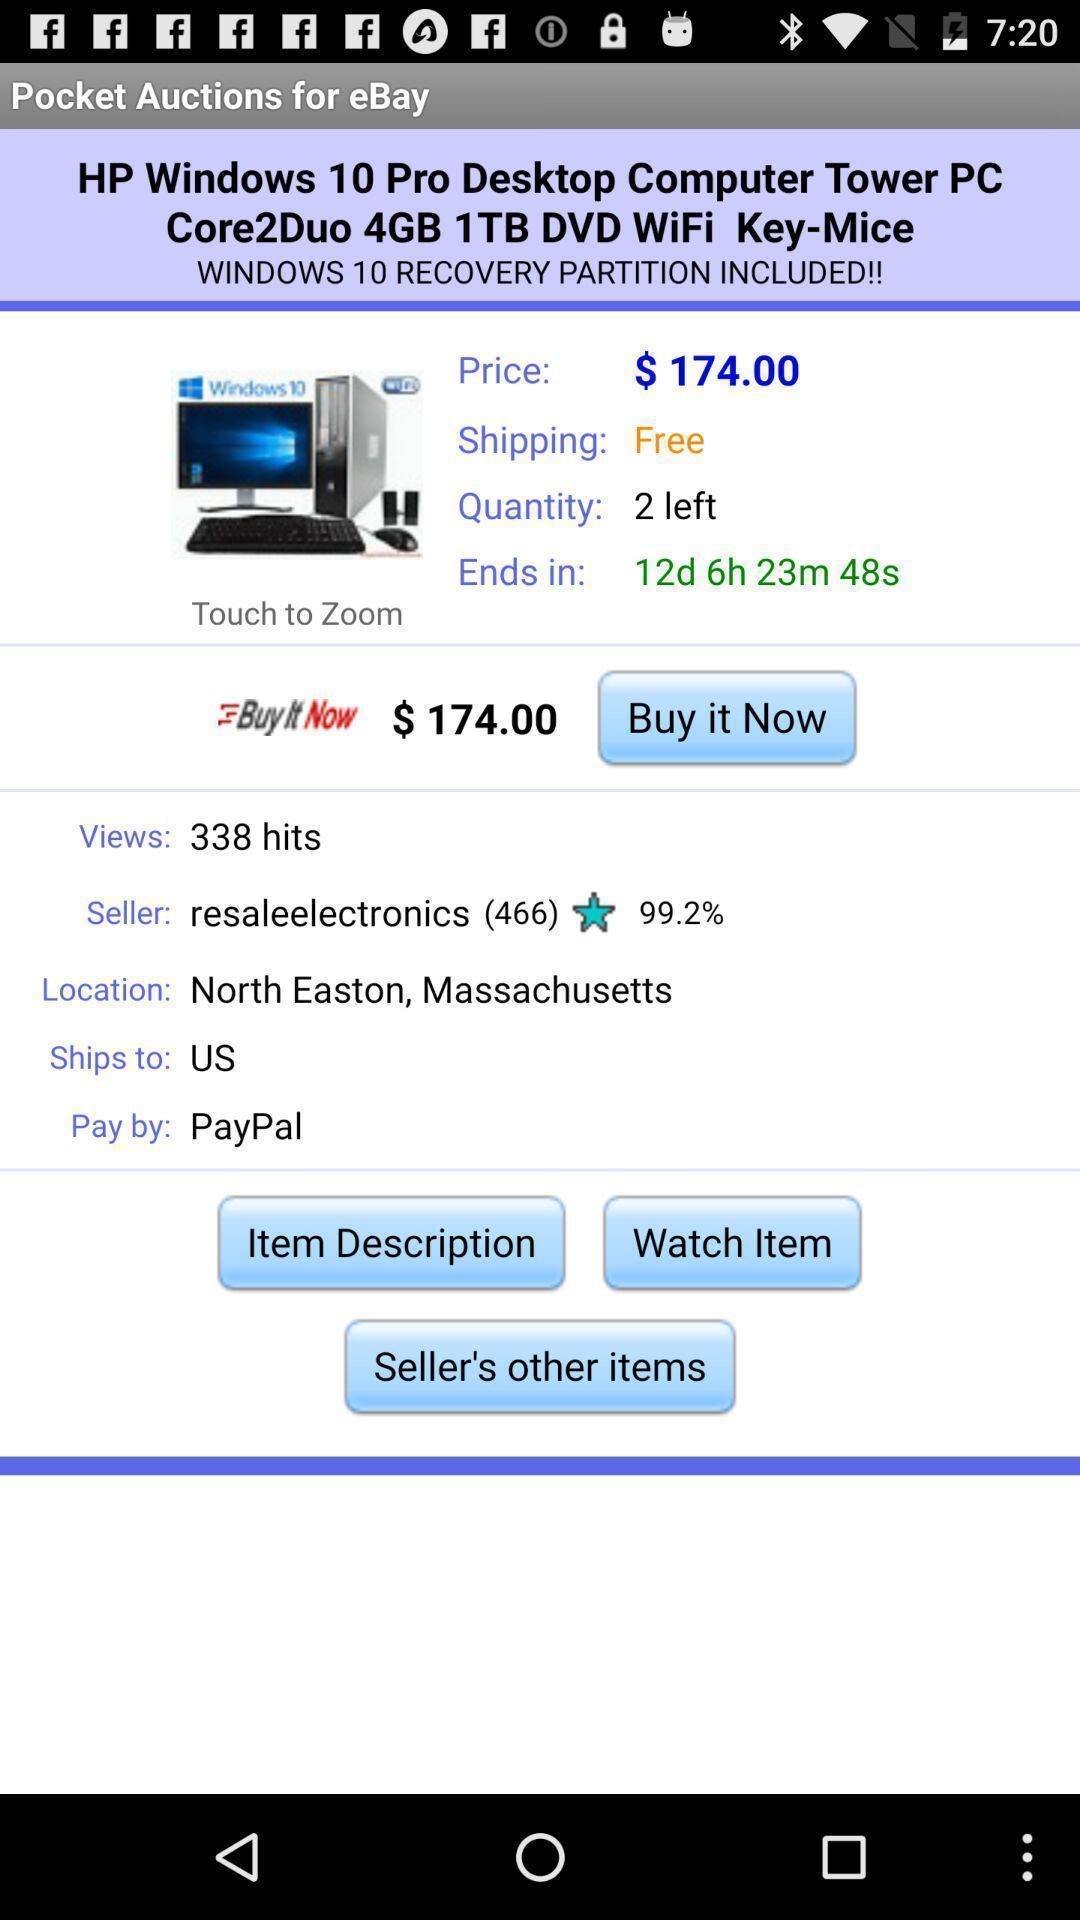What can you discern from this picture? Screen page displaying the details of product in shopping application. 